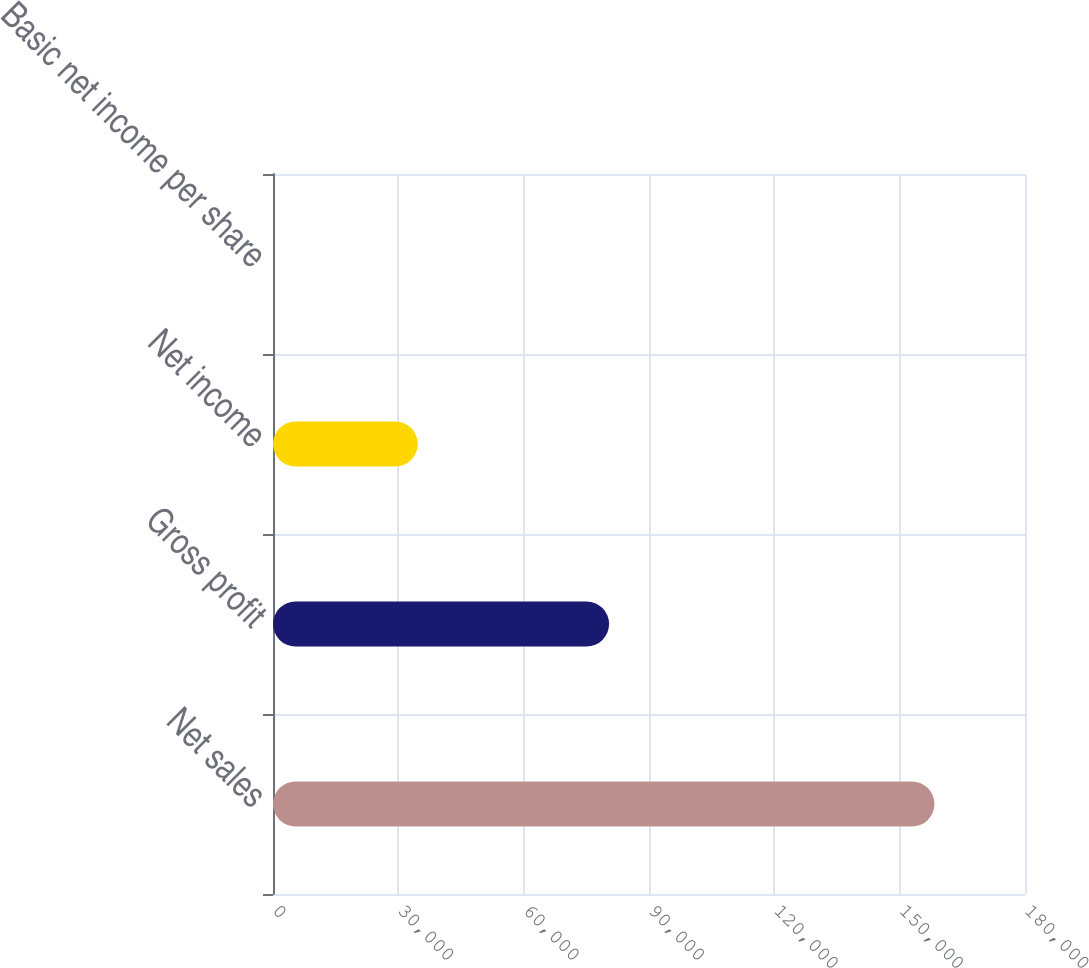Convert chart to OTSL. <chart><loc_0><loc_0><loc_500><loc_500><bar_chart><fcel>Net sales<fcel>Gross profit<fcel>Net income<fcel>Basic net income per share<nl><fcel>158329<fcel>80451<fcel>34656<fcel>0.32<nl></chart> 